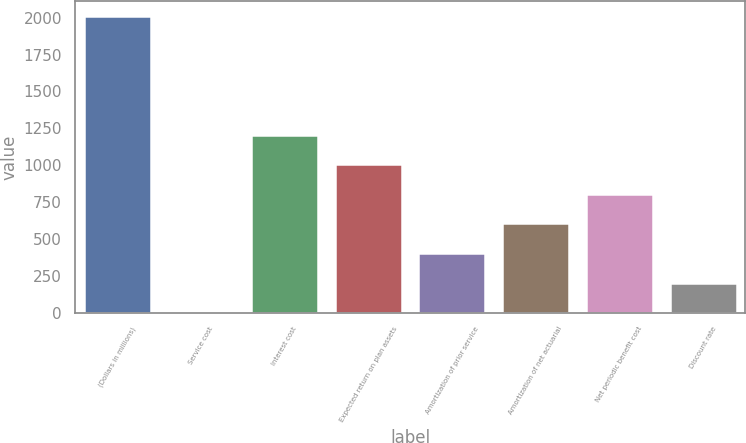Convert chart. <chart><loc_0><loc_0><loc_500><loc_500><bar_chart><fcel>(Dollars in millions)<fcel>Service cost<fcel>Interest cost<fcel>Expected return on plan assets<fcel>Amortization of prior service<fcel>Amortization of net actuarial<fcel>Net periodic benefit cost<fcel>Discount rate<nl><fcel>2011<fcel>3<fcel>1207.8<fcel>1007<fcel>404.6<fcel>605.4<fcel>806.2<fcel>203.8<nl></chart> 